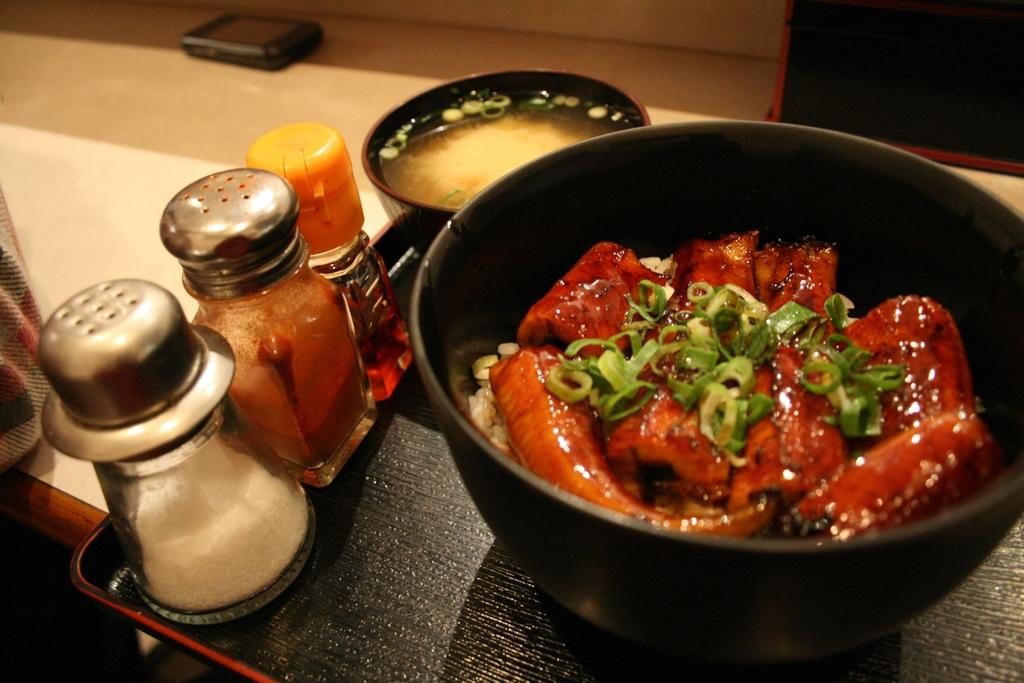What color is the bowl in the image? The bowl in the image is black. What is inside the bowl? The bowl contains food items. Where is the salt jar located in the image? The salt jar is on the left side of the image. What else can be seen on the plate in the image? There are other ingredients jars on a black color plate. Who is the manager of the apples in the image? There are no apples present in the image, so there is no manager for them. 